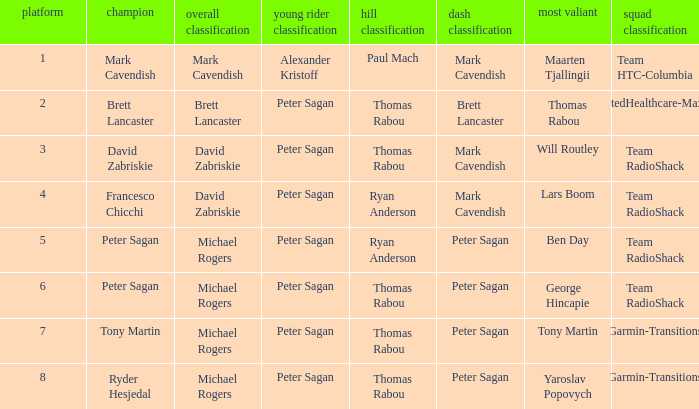When Mark Cavendish wins sprint classification and Maarten Tjallingii wins most courageous, who wins youth classification? Alexander Kristoff. 